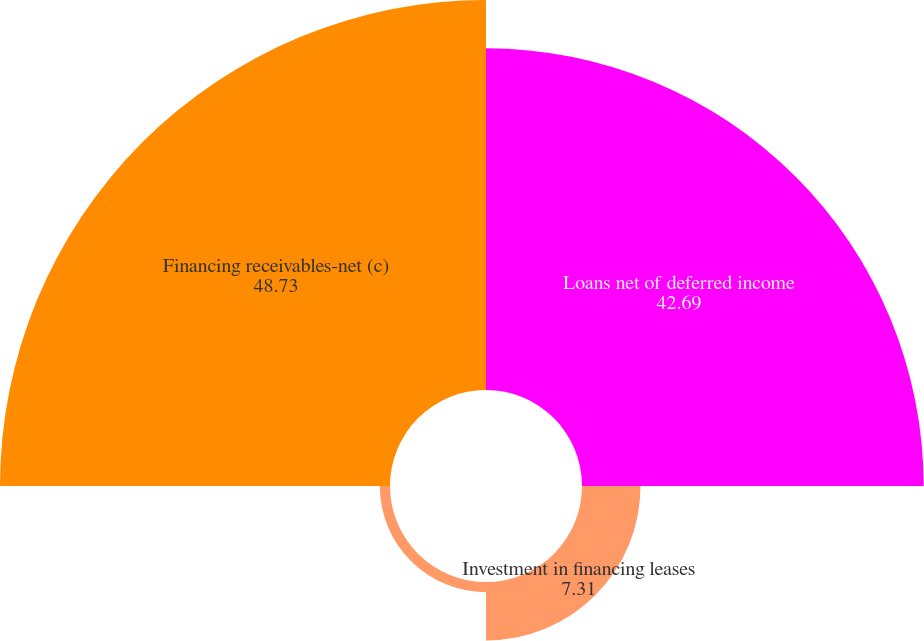<chart> <loc_0><loc_0><loc_500><loc_500><pie_chart><fcel>Loans net of deferred income<fcel>Investment in financing leases<fcel>Less allowance for losses<fcel>Financing receivables-net (c)<nl><fcel>42.69%<fcel>7.31%<fcel>1.27%<fcel>48.73%<nl></chart> 